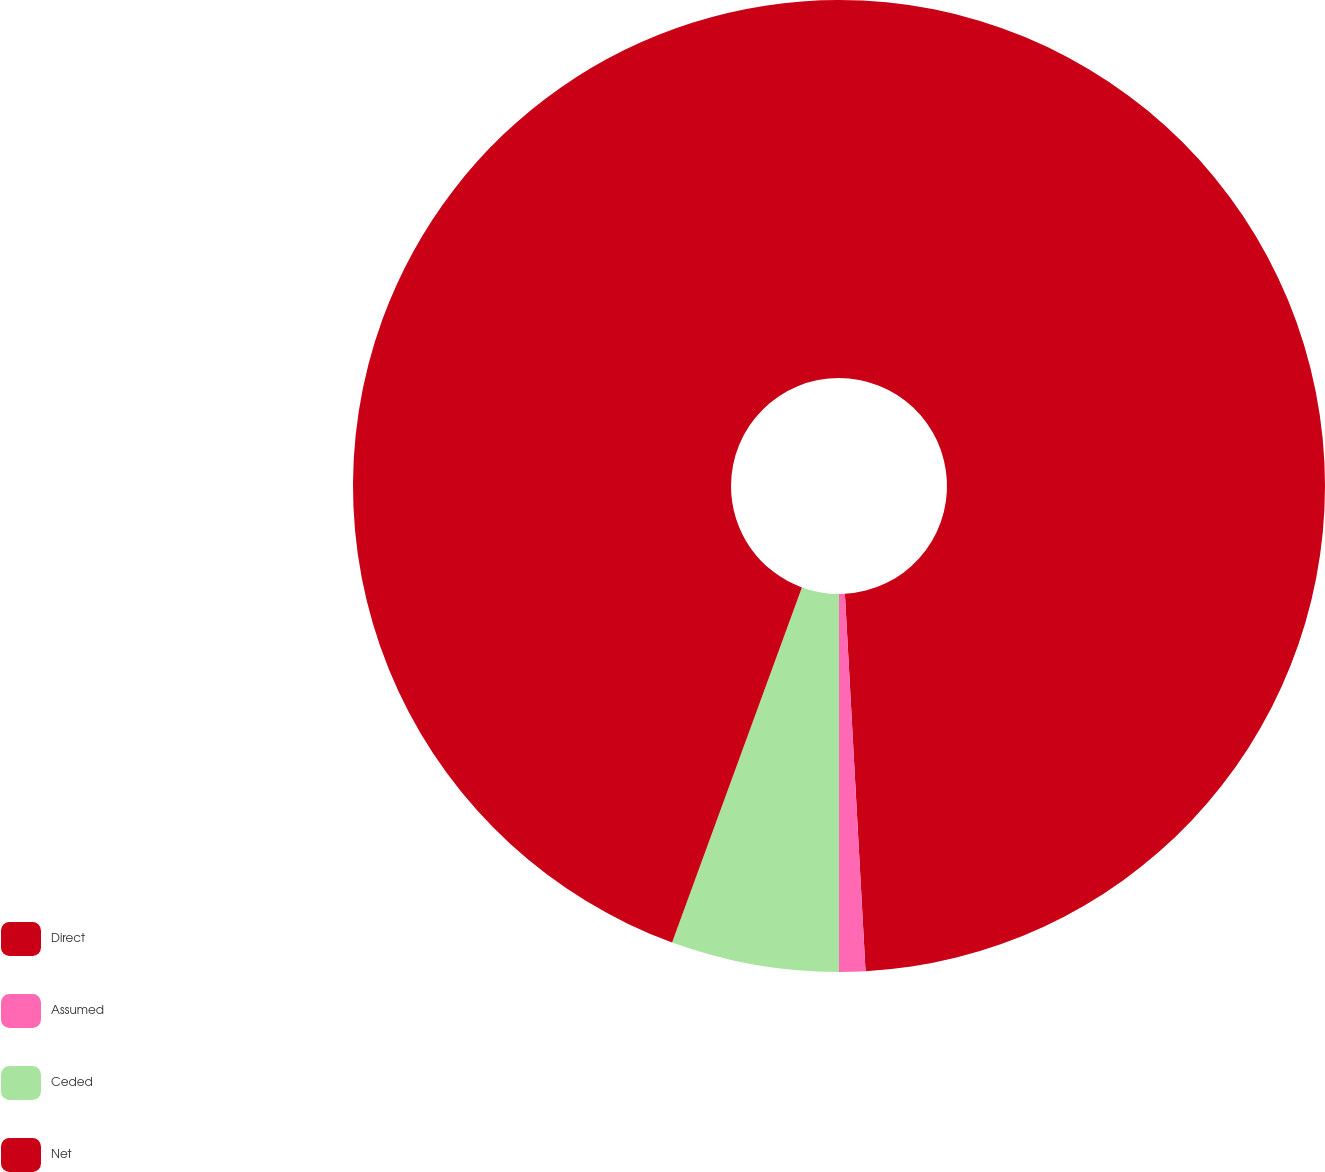Convert chart to OTSL. <chart><loc_0><loc_0><loc_500><loc_500><pie_chart><fcel>Direct<fcel>Assumed<fcel>Ceded<fcel>Net<nl><fcel>49.13%<fcel>0.87%<fcel>5.58%<fcel>44.42%<nl></chart> 